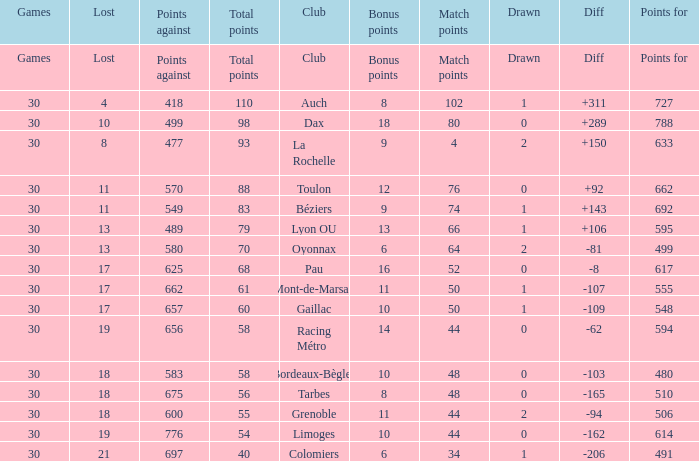What is the diff for a club that has a value of 662 for points for? 92.0. 